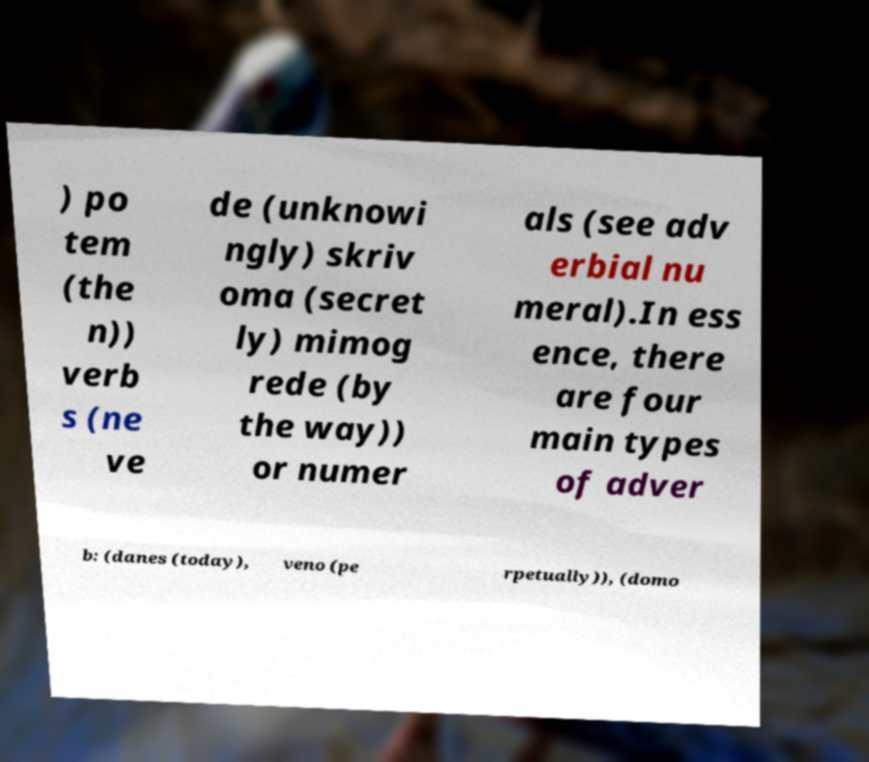Can you read and provide the text displayed in the image?This photo seems to have some interesting text. Can you extract and type it out for me? ) po tem (the n)) verb s (ne ve de (unknowi ngly) skriv oma (secret ly) mimog rede (by the way)) or numer als (see adv erbial nu meral).In ess ence, there are four main types of adver b: (danes (today), veno (pe rpetually)), (domo 